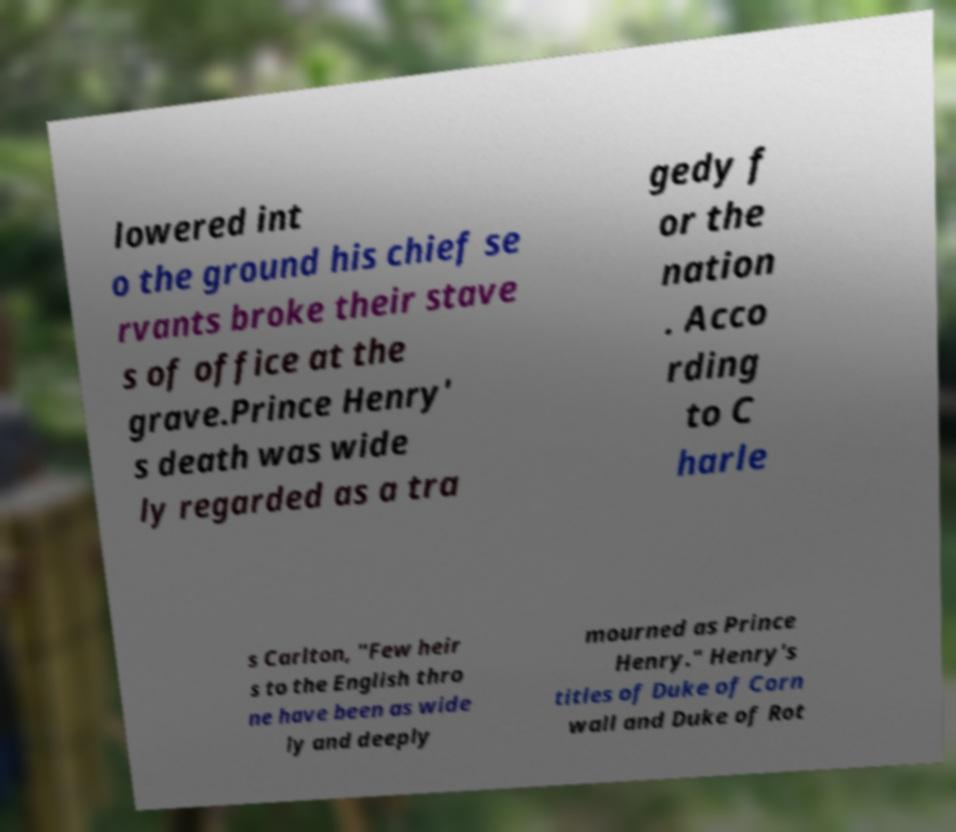Can you accurately transcribe the text from the provided image for me? lowered int o the ground his chief se rvants broke their stave s of office at the grave.Prince Henry' s death was wide ly regarded as a tra gedy f or the nation . Acco rding to C harle s Carlton, "Few heir s to the English thro ne have been as wide ly and deeply mourned as Prince Henry." Henry's titles of Duke of Corn wall and Duke of Rot 